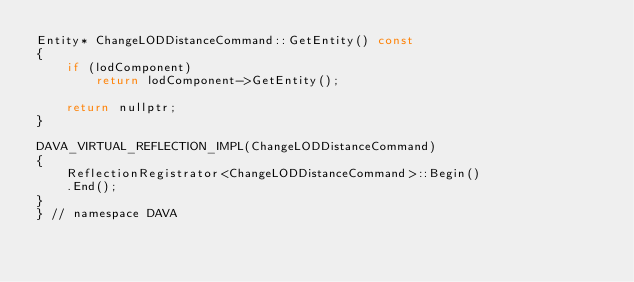Convert code to text. <code><loc_0><loc_0><loc_500><loc_500><_C++_>Entity* ChangeLODDistanceCommand::GetEntity() const
{
    if (lodComponent)
        return lodComponent->GetEntity();

    return nullptr;
}

DAVA_VIRTUAL_REFLECTION_IMPL(ChangeLODDistanceCommand)
{
    ReflectionRegistrator<ChangeLODDistanceCommand>::Begin()
    .End();
}
} // namespace DAVA
</code> 